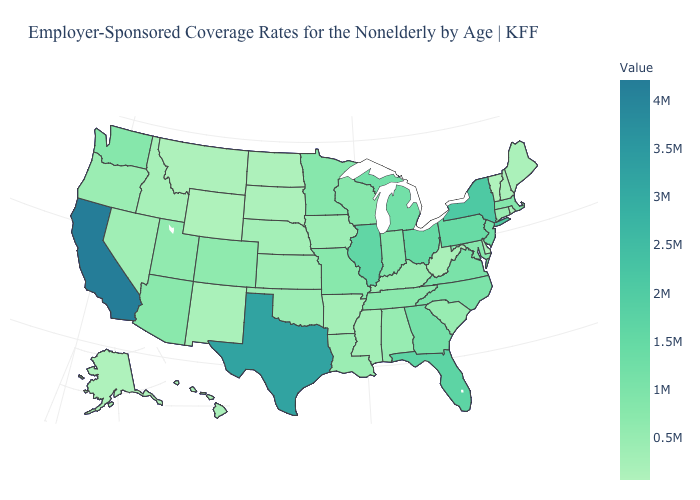Which states have the highest value in the USA?
Quick response, please. California. Does Ohio have a lower value than Texas?
Write a very short answer. Yes. Among the states that border New Jersey , does Delaware have the lowest value?
Keep it brief. Yes. Among the states that border Texas , which have the lowest value?
Short answer required. New Mexico. Which states have the lowest value in the South?
Give a very brief answer. Delaware. 